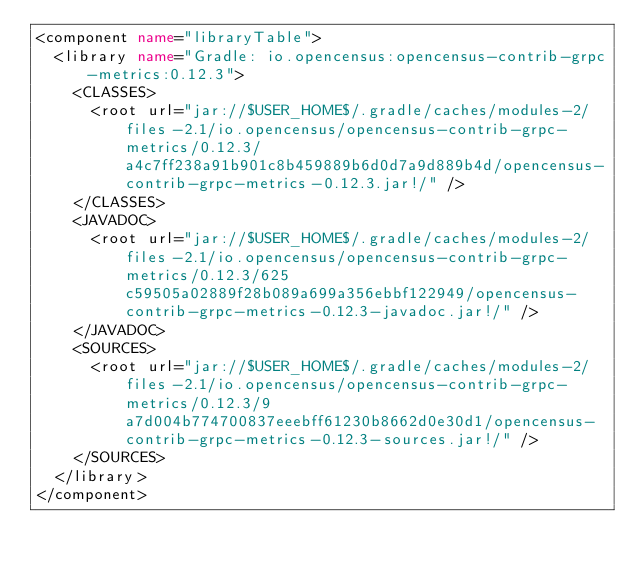Convert code to text. <code><loc_0><loc_0><loc_500><loc_500><_XML_><component name="libraryTable">
  <library name="Gradle: io.opencensus:opencensus-contrib-grpc-metrics:0.12.3">
    <CLASSES>
      <root url="jar://$USER_HOME$/.gradle/caches/modules-2/files-2.1/io.opencensus/opencensus-contrib-grpc-metrics/0.12.3/a4c7ff238a91b901c8b459889b6d0d7a9d889b4d/opencensus-contrib-grpc-metrics-0.12.3.jar!/" />
    </CLASSES>
    <JAVADOC>
      <root url="jar://$USER_HOME$/.gradle/caches/modules-2/files-2.1/io.opencensus/opencensus-contrib-grpc-metrics/0.12.3/625c59505a02889f28b089a699a356ebbf122949/opencensus-contrib-grpc-metrics-0.12.3-javadoc.jar!/" />
    </JAVADOC>
    <SOURCES>
      <root url="jar://$USER_HOME$/.gradle/caches/modules-2/files-2.1/io.opencensus/opencensus-contrib-grpc-metrics/0.12.3/9a7d004b774700837eeebff61230b8662d0e30d1/opencensus-contrib-grpc-metrics-0.12.3-sources.jar!/" />
    </SOURCES>
  </library>
</component></code> 